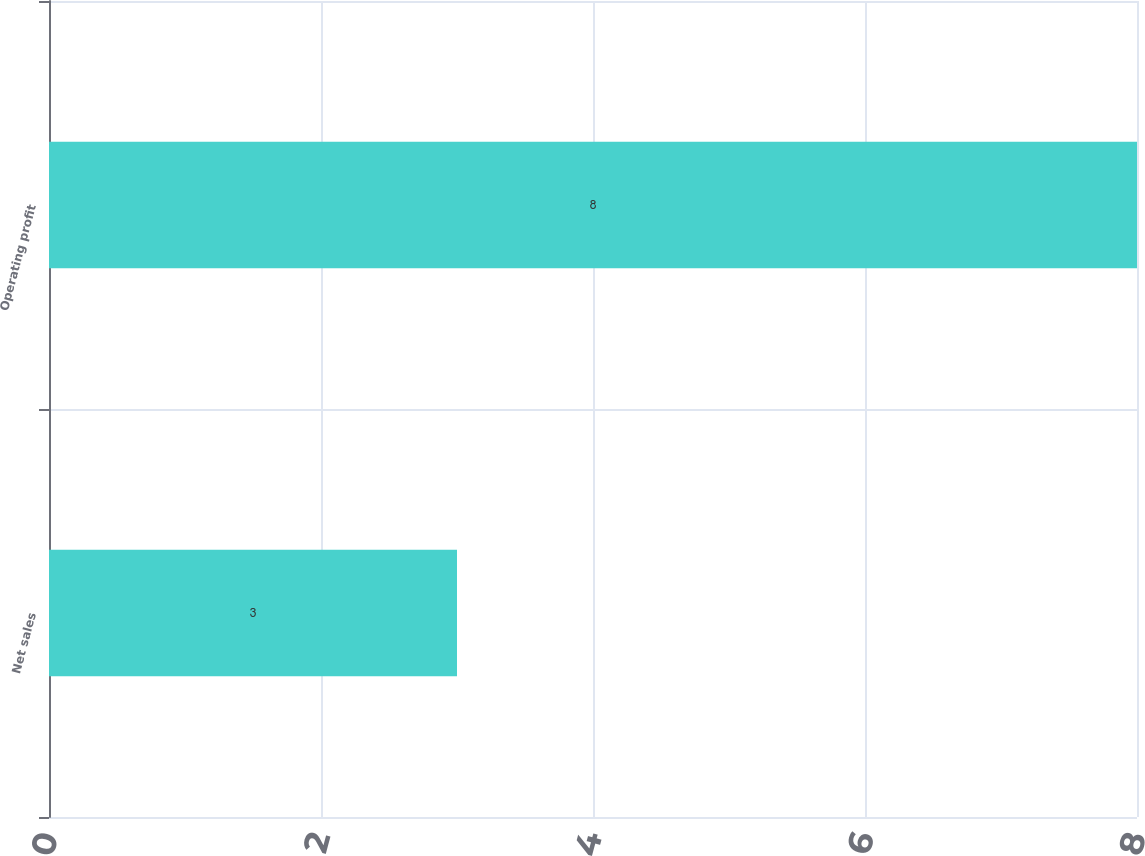Convert chart to OTSL. <chart><loc_0><loc_0><loc_500><loc_500><bar_chart><fcel>Net sales<fcel>Operating profit<nl><fcel>3<fcel>8<nl></chart> 